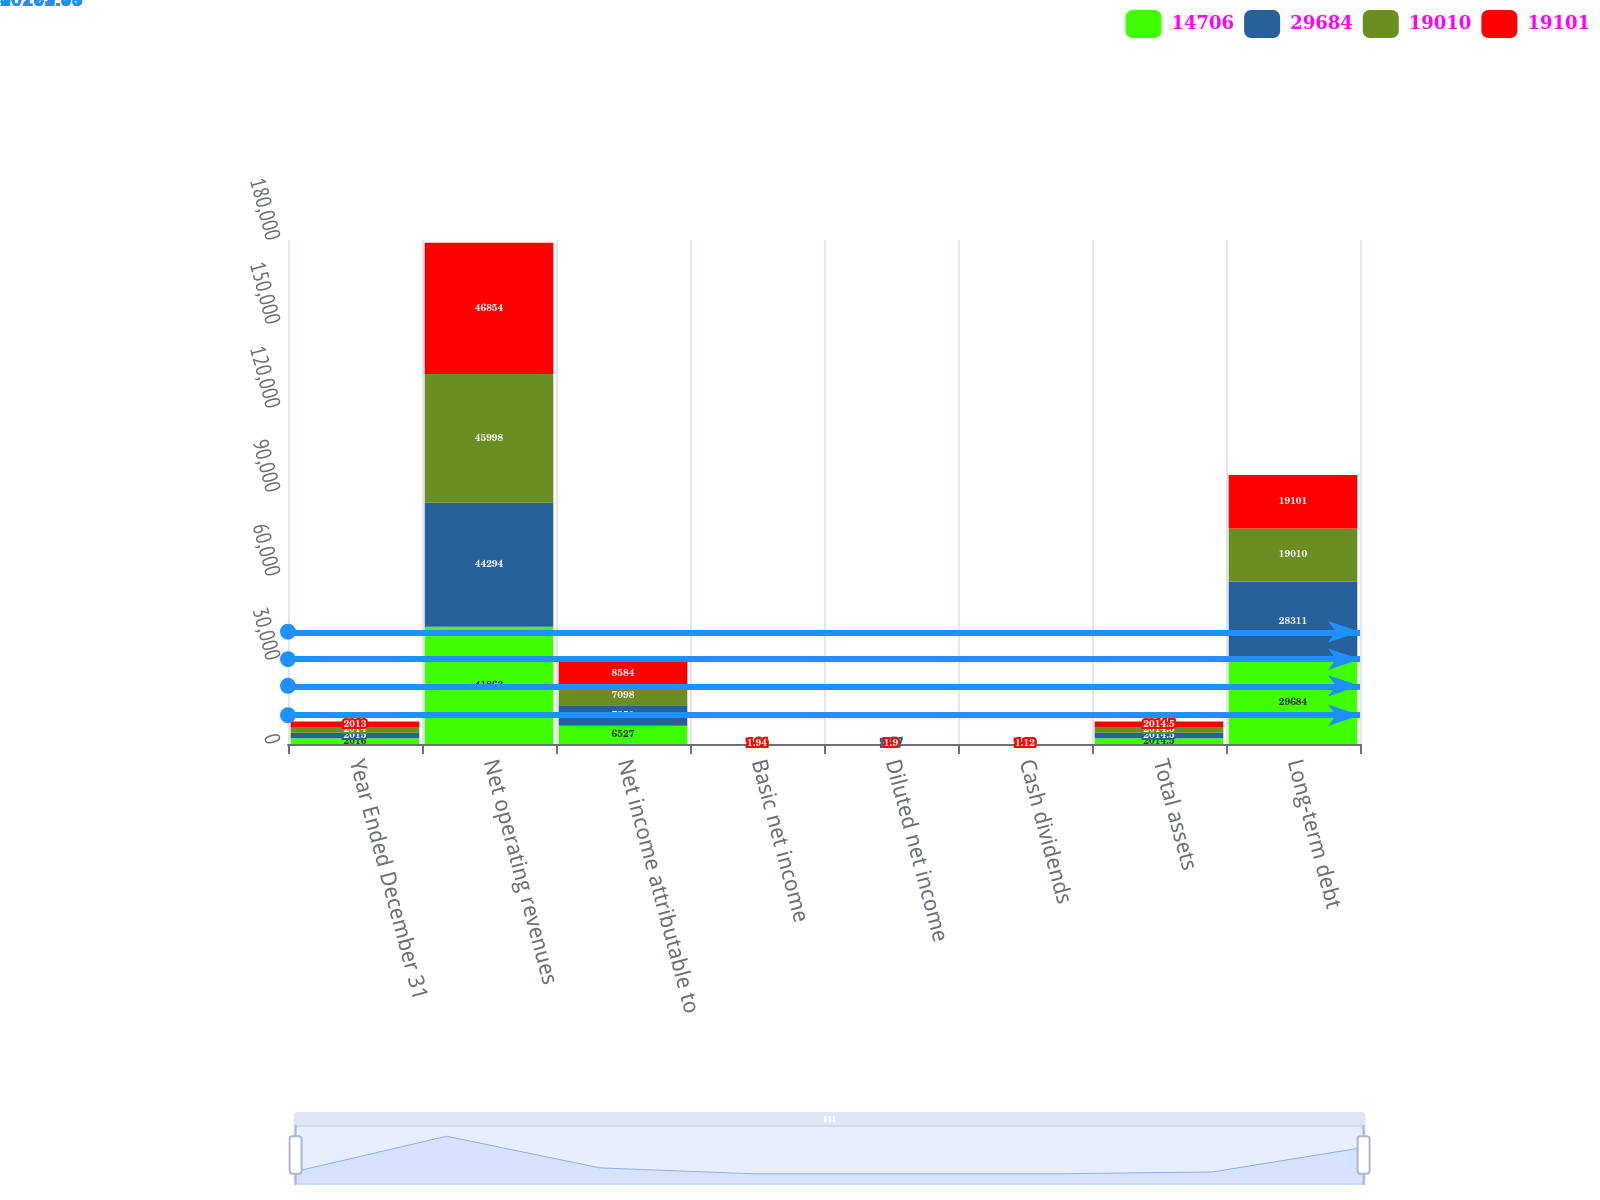Convert chart to OTSL. <chart><loc_0><loc_0><loc_500><loc_500><stacked_bar_chart><ecel><fcel>Year Ended December 31<fcel>Net operating revenues<fcel>Net income attributable to<fcel>Basic net income<fcel>Diluted net income<fcel>Cash dividends<fcel>Total assets<fcel>Long-term debt<nl><fcel>14706<fcel>2016<fcel>41863<fcel>6527<fcel>1.51<fcel>1.49<fcel>1.4<fcel>2014.5<fcel>29684<nl><fcel>29684<fcel>2015<fcel>44294<fcel>7351<fcel>1.69<fcel>1.67<fcel>1.32<fcel>2014.5<fcel>28311<nl><fcel>19010<fcel>2014<fcel>45998<fcel>7098<fcel>1.62<fcel>1.6<fcel>1.22<fcel>2014.5<fcel>19010<nl><fcel>19101<fcel>2013<fcel>46854<fcel>8584<fcel>1.94<fcel>1.9<fcel>1.12<fcel>2014.5<fcel>19101<nl></chart> 